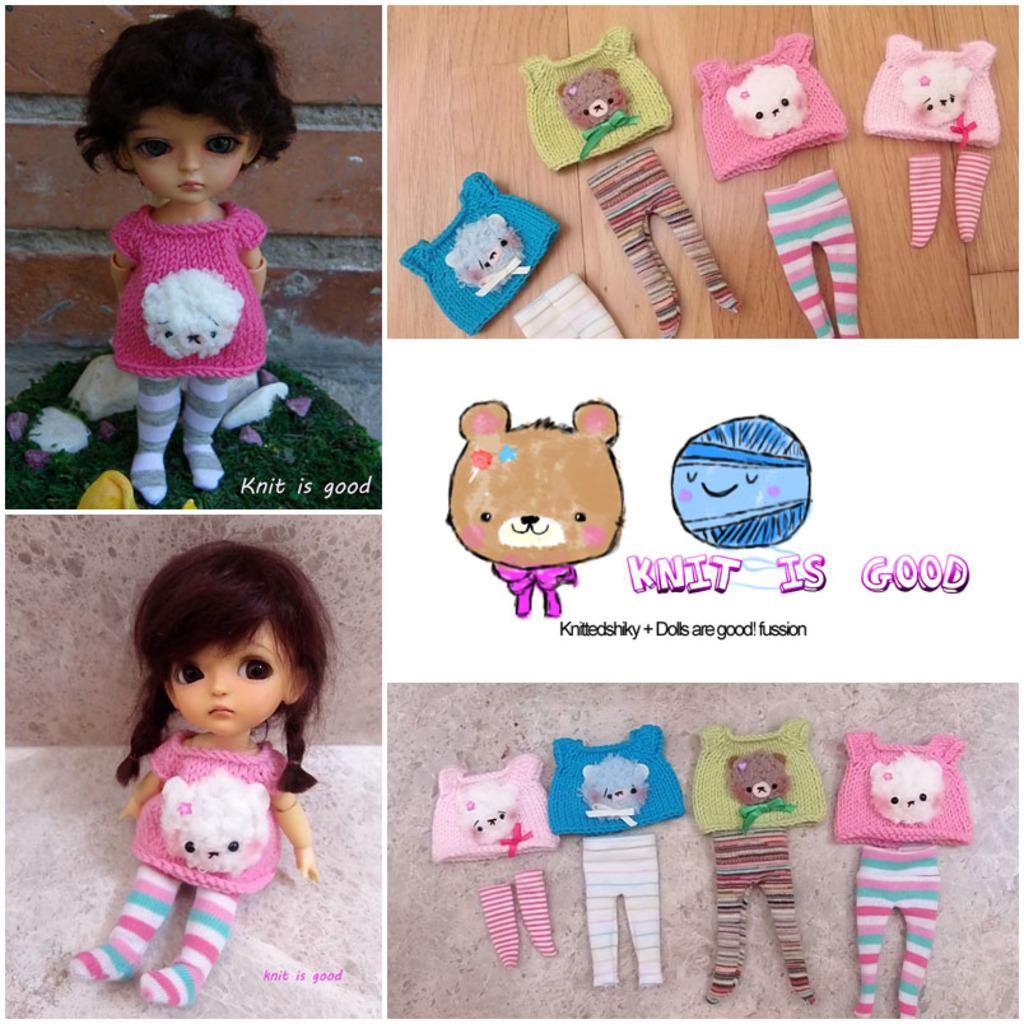What type of objects can be seen in the image? The image contains dolls and clothes. What type of surface is visible in the image? There is grass visible in the image. Is there any text present in the image? Yes, there is text present in the image. Where can the cakes be found in the image? There are no cakes present in the image. What type of activity is taking place in the bath in the image? There is no bath or any related activity depicted in the image. 